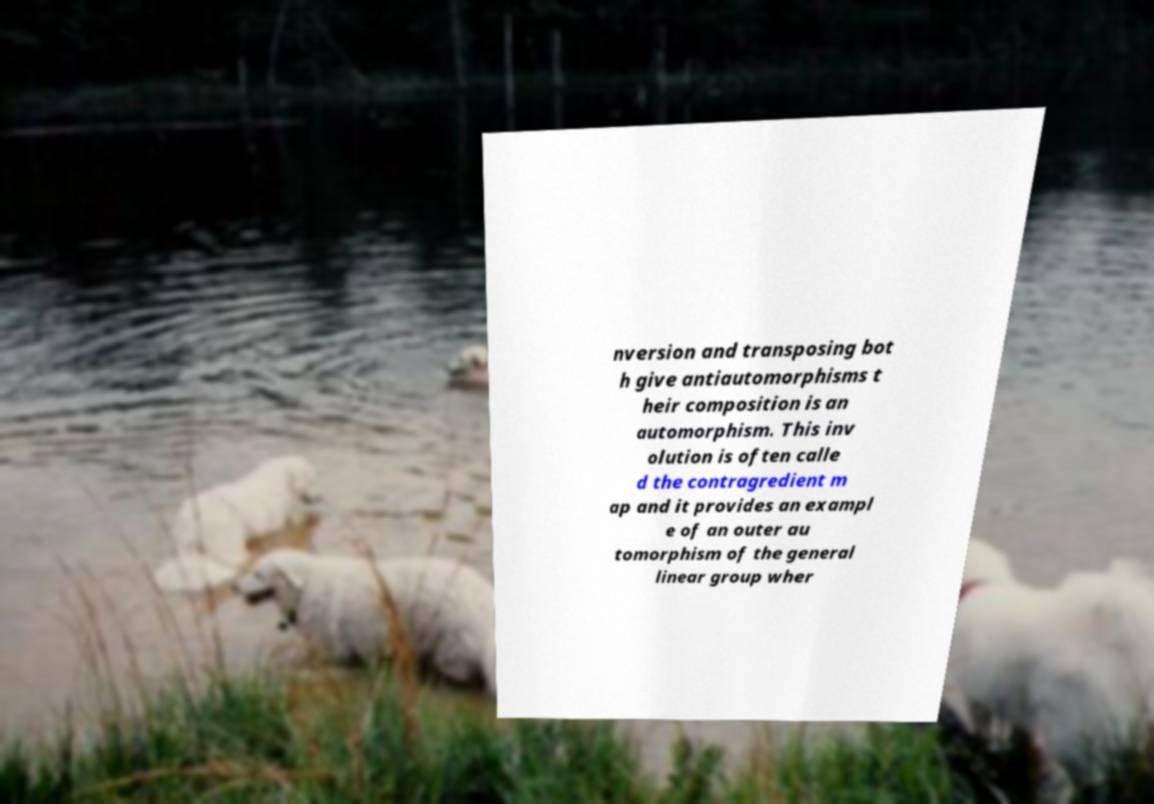Could you assist in decoding the text presented in this image and type it out clearly? nversion and transposing bot h give antiautomorphisms t heir composition is an automorphism. This inv olution is often calle d the contragredient m ap and it provides an exampl e of an outer au tomorphism of the general linear group wher 